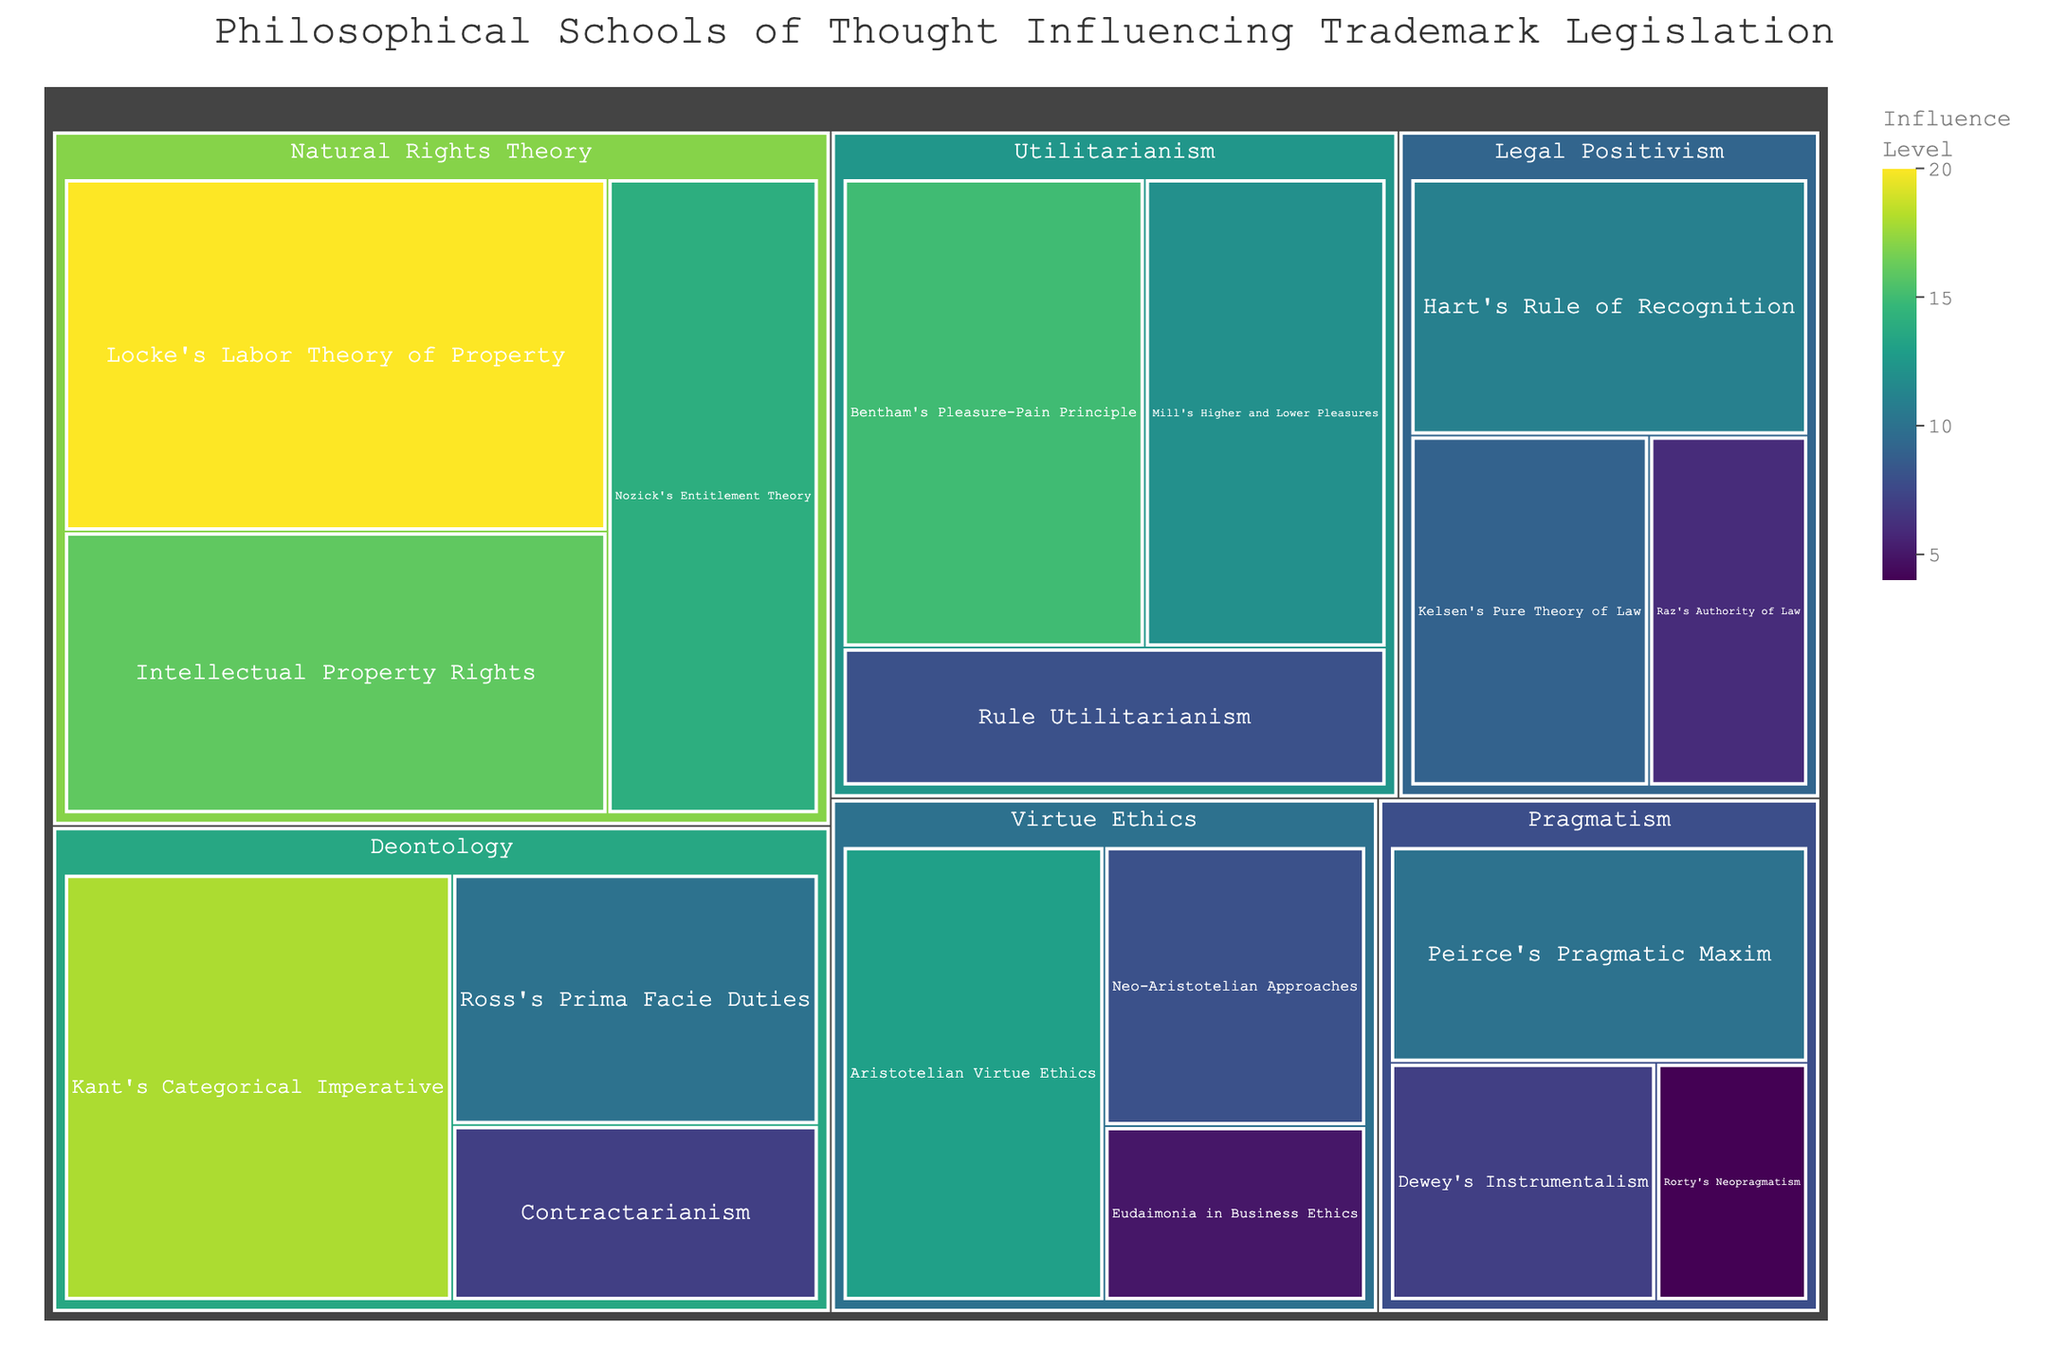Which philosophical school of thought has the highest total influence? First, we sum the values for each category. Utilitarianism: 15 + 12 + 8 = 35. Deontology: 18 + 10 + 7 = 35. Natural Rights Theory: 20 + 14 + 16 = 50. Legal Positivism: 11 + 9 + 6 = 26. Virtue Ethics: 13 + 8 + 5 = 26. Pragmatism: 10 + 7 + 4 = 21. The highest total value is 50 for Natural Rights Theory.
Answer: Natural Rights Theory Which subcategory within Deontology has the highest influence level? Under Deontology, the subcategories and respective values are Kant's Categorical Imperative: 18, Ross's Prima Facie Duties: 10, and Contractarianism: 7. The highest value is 18 for Kant's Categorical Imperative.
Answer: Kant's Categorical Imperative How does the influence of Locke's Labor Theory of Property compare to that of Bentham's Pleasure-Pain Principle? The influence level for Locke's Labor Theory of Property is 20, whereas for Bentham's Pleasure-Pain Principle it is 15. Therefore, Locke's Labor Theory of Property has a higher influence level.
Answer: Locke's Labor Theory of Property has a higher influence level What is the total influence level of all subcategories within Legal Positivism? Summing the values for Legal Positivism: Hart's Rule of Recognition (11) + Kelsen's Pure Theory of Law (9) + Raz's Authority of Law (6) gives a total of 26.
Answer: 26 What is the difference in the influence level between Mill's Higher and Lower Pleasures and Ross's Prima Facie Duties? Mill's Higher and Lower Pleasures have an influence level of 12, and Ross's Prima Facie Duties have an influence level of 10. The difference is 12 - 10 = 2.
Answer: 2 Which subcategory has the lowest influence level in the entire treemap? By looking at the lowest value in the entire dataset, we find Rorty's Neopragmatism with an influence level of 4.
Answer: Rorty's Neopragmatism How many subcategories in the treemap have an influence level greater than 10? From the data: Bentham's Pleasure-Pain Principle (15), Locke's Labor Theory of Property (20), Nozick's Entitlement Theory (14), Intellectual Property Rights (16), Aristotelian Virtue Ethics (13), Kant's Categorical Imperative (18), Mill's Higher and Lower Pleasures (12), and Hart's Rule of Recognition (11). There are 8 subcategories with values greater than 10.
Answer: 8 What is the average influence level of subcategories within Pragmatism? The subcategories within Pragmatism are Peirce's Pragmatic Maxim (10), Dewey's Instrumentalism (7), and Rorty's Neopragmatism (4). The sum is 10 + 7 + 4 = 21. Dividing by the number of subcategories, 21/3 = 7.
Answer: 7 